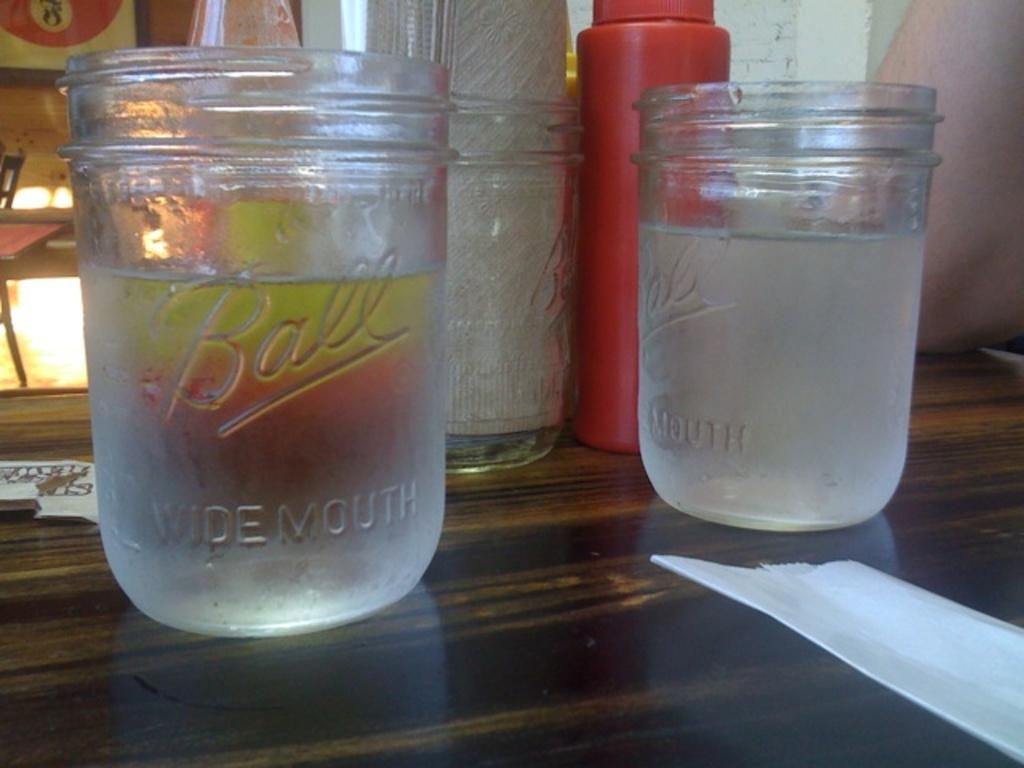<image>
Offer a succinct explanation of the picture presented. two ball wide mouth jars filled with clear liquid on a table with a napkin, ketchup dispenser and other items 